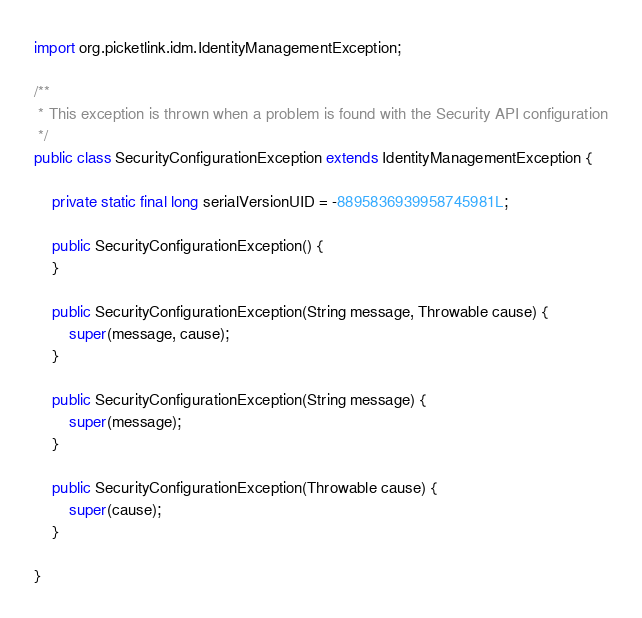<code> <loc_0><loc_0><loc_500><loc_500><_Java_>
import org.picketlink.idm.IdentityManagementException;

/**
 * This exception is thrown when a problem is found with the Security API configuration
 */
public class SecurityConfigurationException extends IdentityManagementException {

    private static final long serialVersionUID = -8895836939958745981L;

    public SecurityConfigurationException() {
    }

    public SecurityConfigurationException(String message, Throwable cause) {
        super(message, cause);
    }

    public SecurityConfigurationException(String message) {
        super(message);
    }

    public SecurityConfigurationException(Throwable cause) {
        super(cause);
    }

}
</code> 